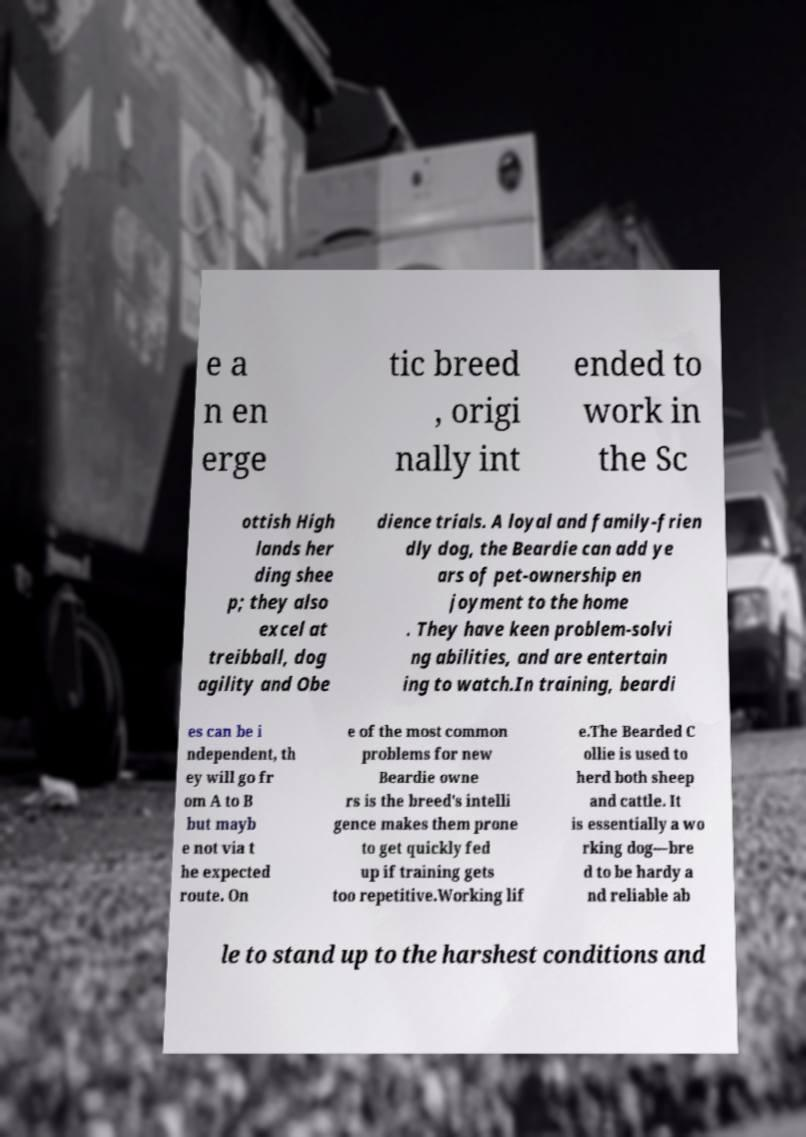There's text embedded in this image that I need extracted. Can you transcribe it verbatim? e a n en erge tic breed , origi nally int ended to work in the Sc ottish High lands her ding shee p; they also excel at treibball, dog agility and Obe dience trials. A loyal and family-frien dly dog, the Beardie can add ye ars of pet-ownership en joyment to the home . They have keen problem-solvi ng abilities, and are entertain ing to watch.In training, beardi es can be i ndependent, th ey will go fr om A to B but mayb e not via t he expected route. On e of the most common problems for new Beardie owne rs is the breed's intelli gence makes them prone to get quickly fed up if training gets too repetitive.Working lif e.The Bearded C ollie is used to herd both sheep and cattle. It is essentially a wo rking dog—bre d to be hardy a nd reliable ab le to stand up to the harshest conditions and 